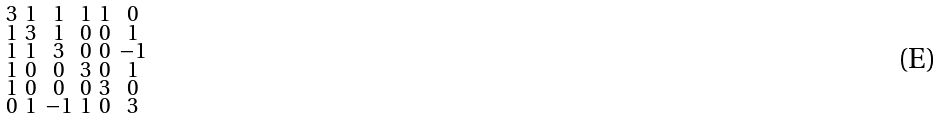<formula> <loc_0><loc_0><loc_500><loc_500>\begin{smallmatrix} 3 & 1 & 1 & 1 & 1 & 0 \\ 1 & 3 & 1 & 0 & 0 & 1 \\ 1 & 1 & 3 & 0 & 0 & - 1 \\ 1 & 0 & 0 & 3 & 0 & 1 \\ 1 & 0 & 0 & 0 & 3 & 0 \\ 0 & 1 & - 1 & 1 & 0 & 3 \end{smallmatrix}</formula> 